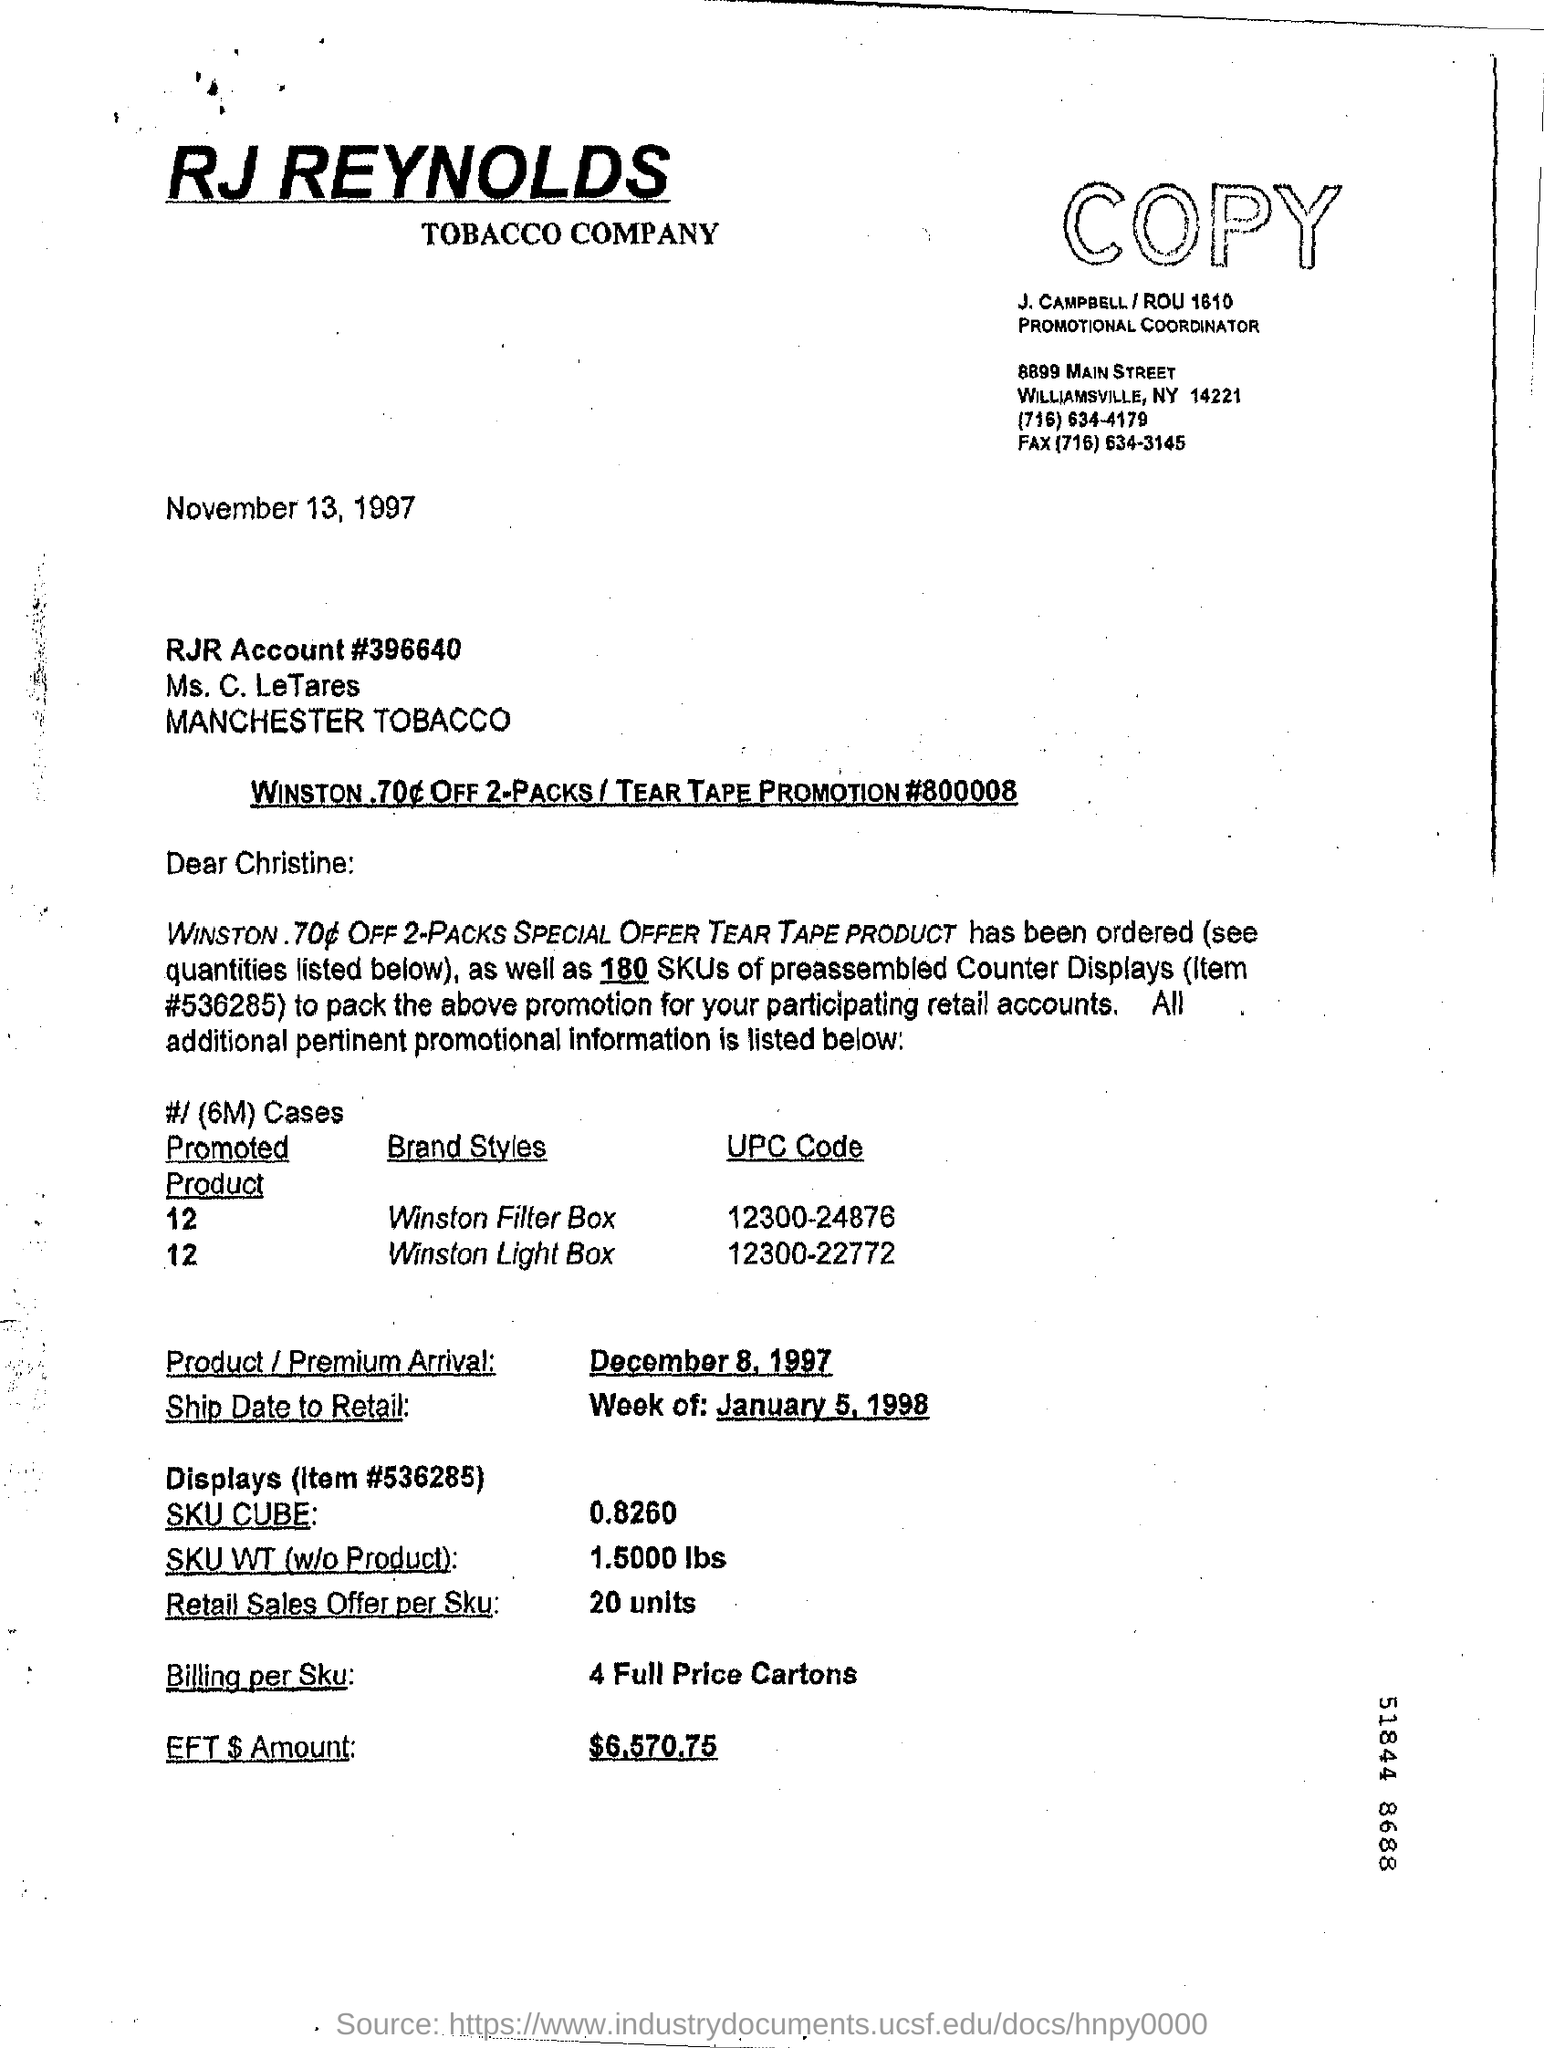Identify some key points in this picture. The Retail Sales offer per SKU is 20 units. The date on the document is November 13, 1997. The EFT amount is $6,570.75. The ship date to retail for the week of January 5, 1998 is [insert date]. 